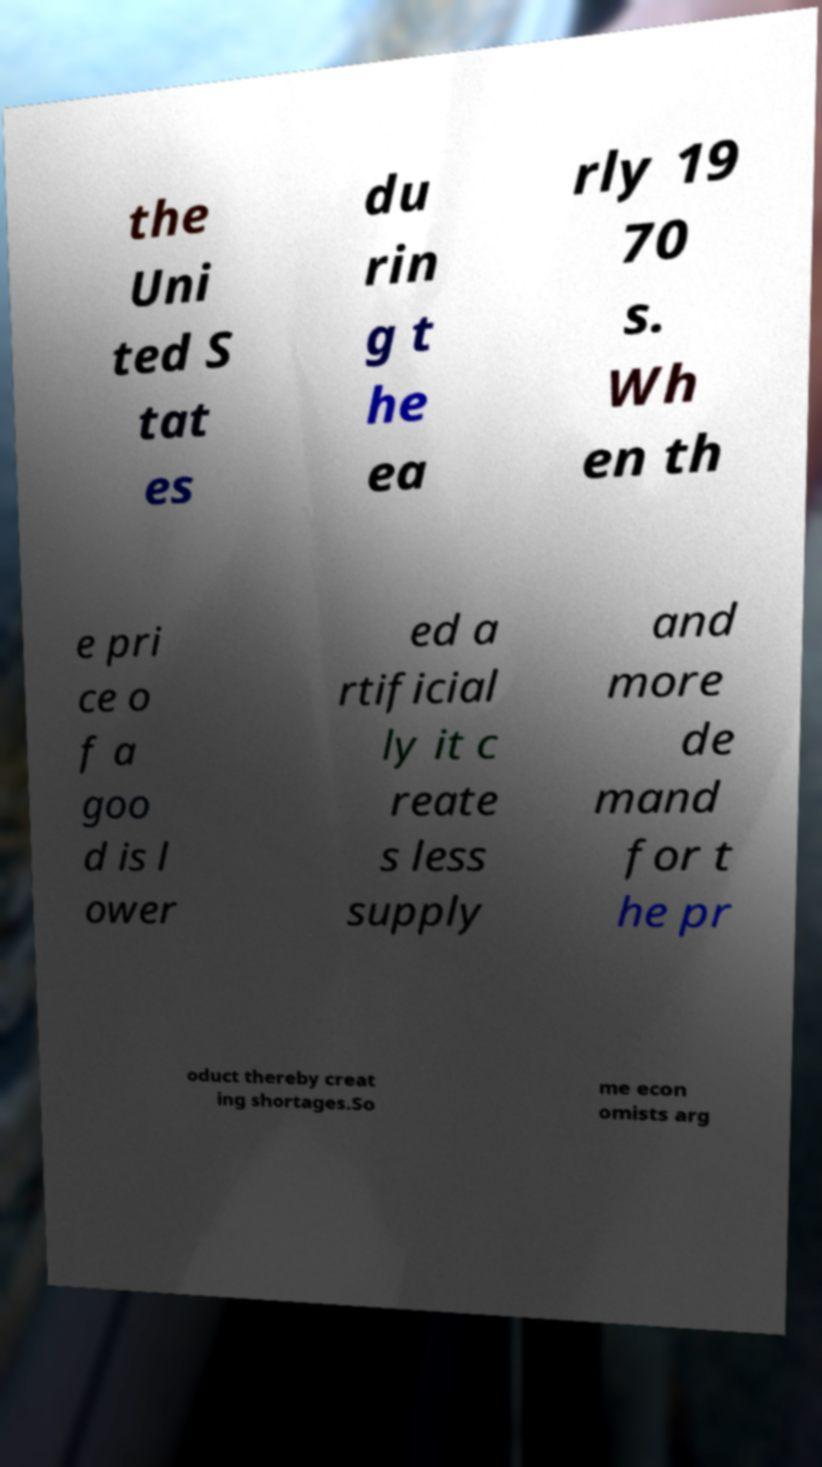I need the written content from this picture converted into text. Can you do that? the Uni ted S tat es du rin g t he ea rly 19 70 s. Wh en th e pri ce o f a goo d is l ower ed a rtificial ly it c reate s less supply and more de mand for t he pr oduct thereby creat ing shortages.So me econ omists arg 